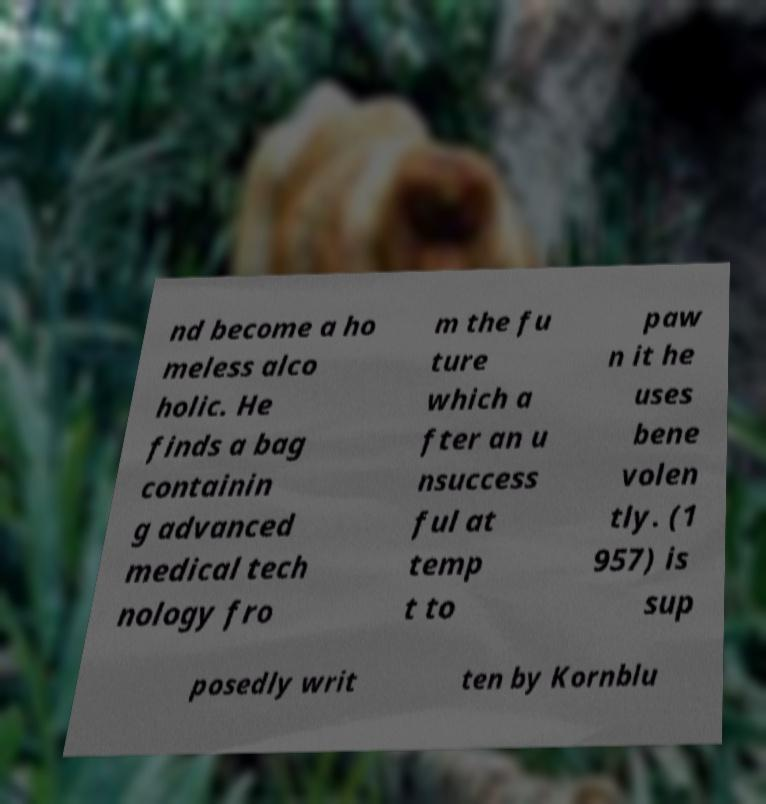For documentation purposes, I need the text within this image transcribed. Could you provide that? nd become a ho meless alco holic. He finds a bag containin g advanced medical tech nology fro m the fu ture which a fter an u nsuccess ful at temp t to paw n it he uses bene volen tly. (1 957) is sup posedly writ ten by Kornblu 